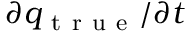Convert formula to latex. <formula><loc_0><loc_0><loc_500><loc_500>q _ { t r u e } / t</formula> 